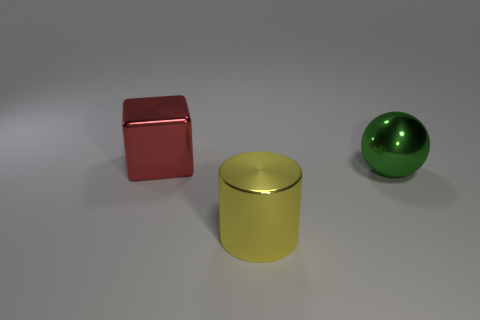Does the large metallic sphere have the same color as the metal cube?
Your response must be concise. No. What is the size of the shiny ball that is right of the large yellow metal object?
Provide a succinct answer. Large. There is a big shiny thing behind the metal ball; is its color the same as the object that is on the right side of the shiny cylinder?
Provide a succinct answer. No. What number of other objects are there of the same shape as the big green thing?
Provide a short and direct response. 0. Are there an equal number of big metallic blocks in front of the sphere and big yellow shiny things that are left of the large block?
Provide a succinct answer. Yes. Is the thing that is to the left of the yellow shiny cylinder made of the same material as the thing that is right of the big cylinder?
Your answer should be very brief. Yes. How many other objects are the same size as the metallic ball?
Provide a short and direct response. 2. How many objects are either large shiny balls or things behind the yellow cylinder?
Your answer should be compact. 2. Is the number of cubes behind the big cube the same as the number of big red things?
Provide a succinct answer. No. The red object that is the same material as the yellow cylinder is what shape?
Make the answer very short. Cube. 